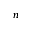<formula> <loc_0><loc_0><loc_500><loc_500>n</formula> 